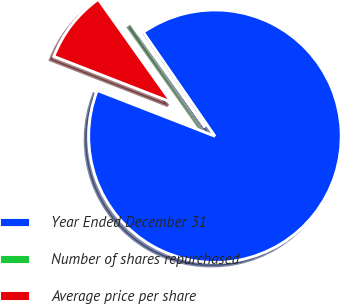Convert chart to OTSL. <chart><loc_0><loc_0><loc_500><loc_500><pie_chart><fcel>Year Ended December 31<fcel>Number of shares repurchased<fcel>Average price per share<nl><fcel>90.52%<fcel>0.23%<fcel>9.26%<nl></chart> 